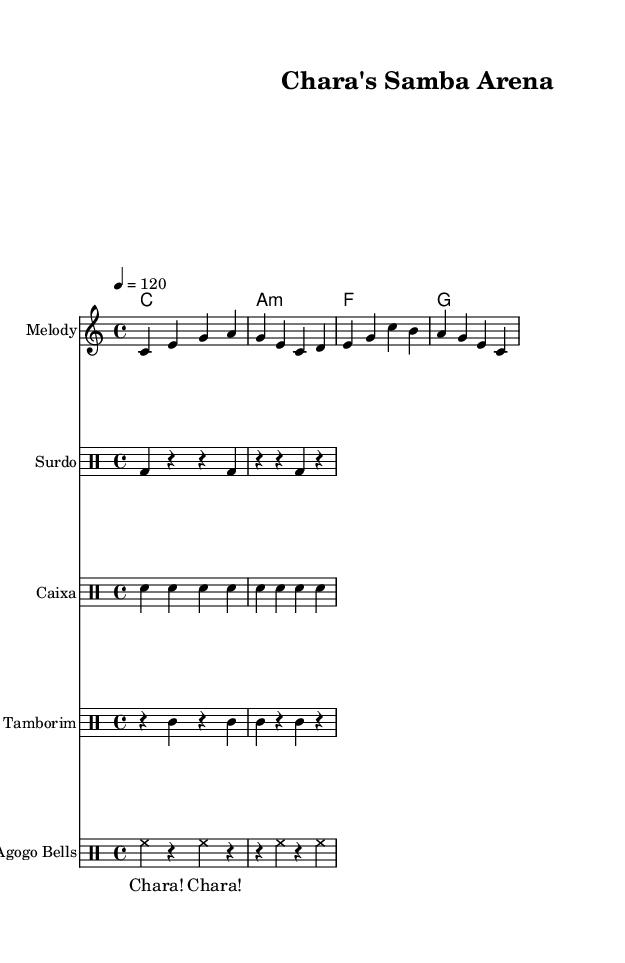What is the key signature of this music? The key signature is indicated in the global settings at the beginning of the sheet music. It specifies that this piece is in C major, which has no sharps or flats.
Answer: C major What is the time signature of this music? The time signature is also specified in the global settings. It shows that the music is in 4/4 time, meaning there are four beats in each measure and the quarter note gets one beat.
Answer: 4/4 What is the tempo marking of this music? The tempo is indicated in the global section as 4 = 120, which means there should be 120 quarter notes played per minute. This gives a lively pace suitable for samba rhythms.
Answer: 120 What type of drum pattern is used for the surdo? The surdo pattern is noted in the drum staff section, where 'bd' represents bass drum hits in a simple rhythmic pattern with rests in between.
Answer: Bass drum How many different instruments are featured in this piece? By examining the score layout, we can see there are five groups: one for chords, one for melody, and four for different percussion instruments. Therefore, this piece features five different instruments.
Answer: Five Which instrument plays the crowd chant? The crowd chant is indicated at the bottom of the score, and it is notated separately from the instrumentation, suggesting it involves vocal elements from the audience.
Answer: Voices What is the primary rhythm style represented in this music? The overall structure follows traditional samba rhythms, identifiable by the specific patterns provided in the drum sections and the lively melody line, reflecting Brazilian samba's energetic nature.
Answer: Samba 